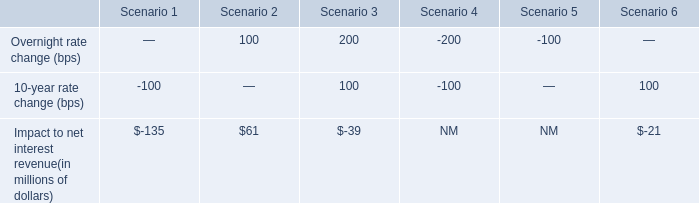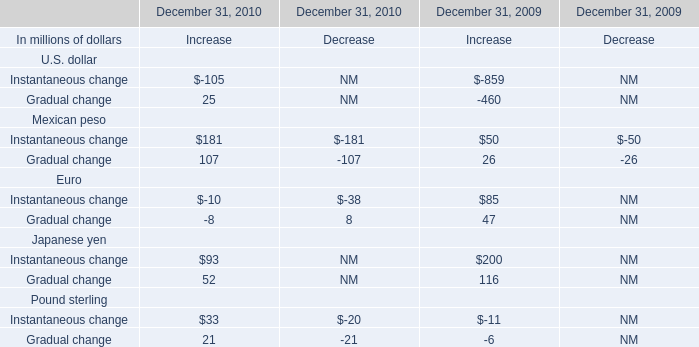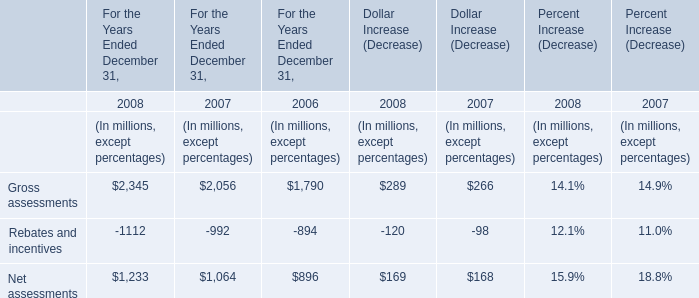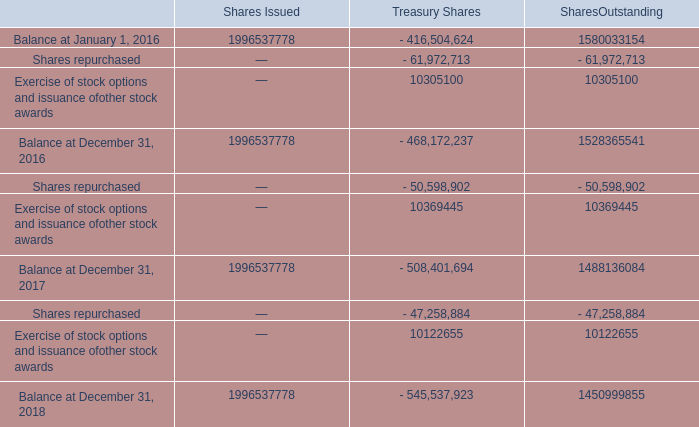What is the ratio of Gradual change to the total for U.S. dollar in 2010 for Increase? 
Computations: (25 / -460)
Answer: -0.05435. 